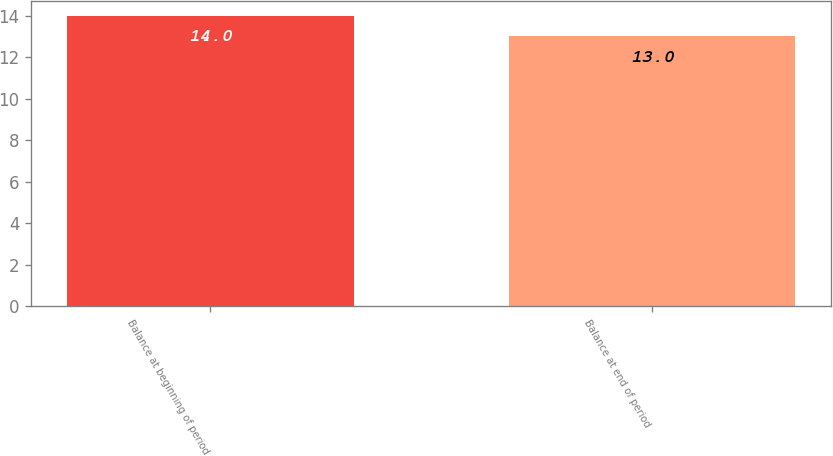Convert chart. <chart><loc_0><loc_0><loc_500><loc_500><bar_chart><fcel>Balance at beginning of period<fcel>Balance at end of period<nl><fcel>14<fcel>13<nl></chart> 